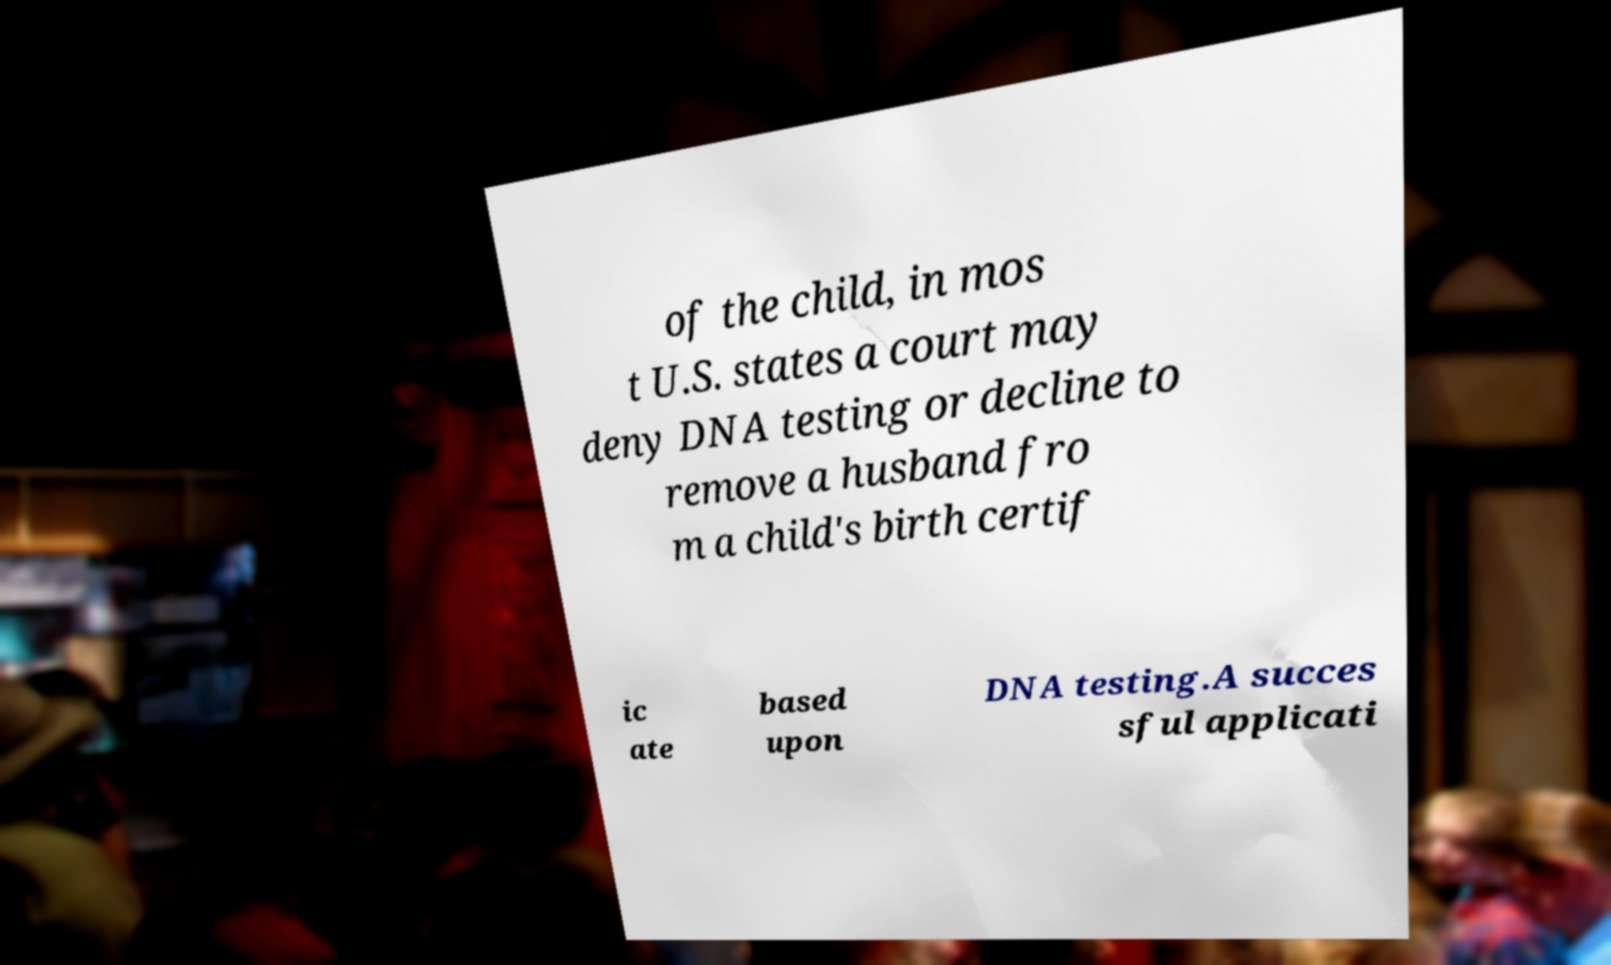Please identify and transcribe the text found in this image. of the child, in mos t U.S. states a court may deny DNA testing or decline to remove a husband fro m a child's birth certif ic ate based upon DNA testing.A succes sful applicati 